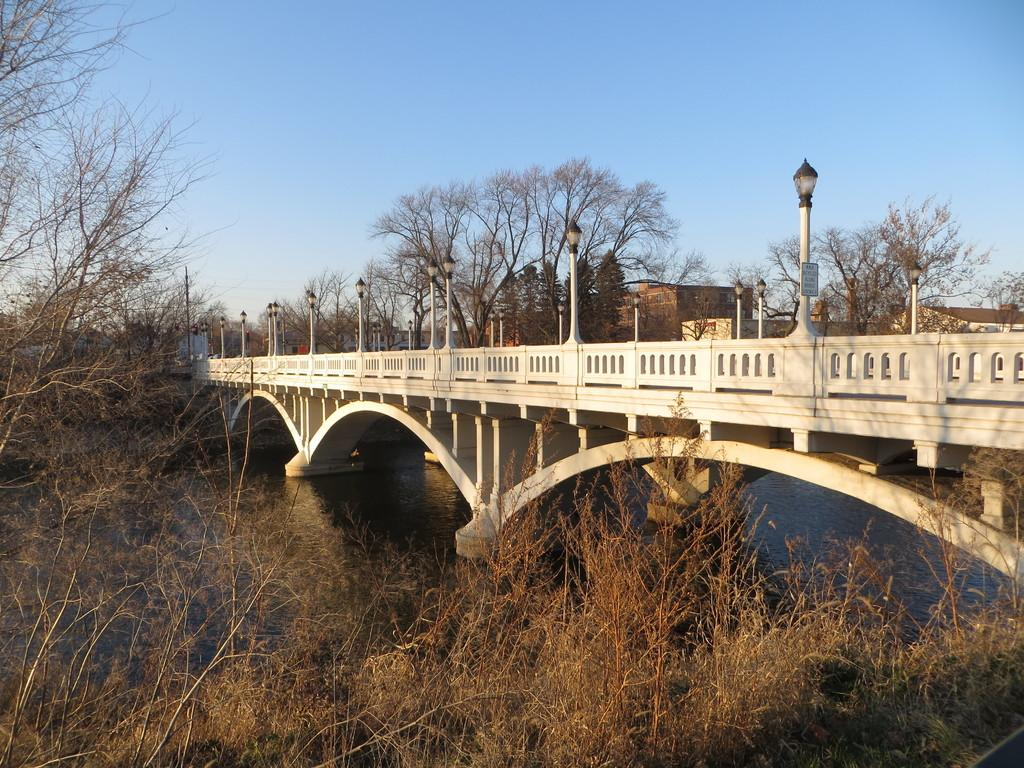What structure can be seen in the image? There is a bridge in the image. What natural element is visible in the image? There is water visible in the image. What type of illumination is present in the image? There are lights in the image. What type of vegetation is present in the image? There are trees in the image. What can be seen in the background of the image? The sky is visible in the background of the image. How does the bridge kick the ball in the image? The bridge does not kick a ball in the image; it is a stationary structure. 